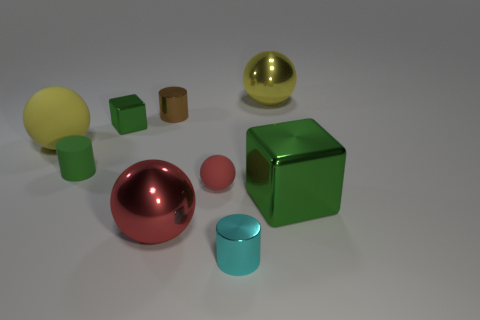The rubber thing that is the same color as the big metal cube is what size?
Ensure brevity in your answer.  Small. What number of other things are the same size as the brown cylinder?
Offer a terse response. 4. There is a green block that is behind the small green rubber cylinder; what is its material?
Your answer should be very brief. Metal. Do the yellow metal object and the cyan thing have the same shape?
Make the answer very short. No. How many other things are the same shape as the large green thing?
Your answer should be very brief. 1. What is the color of the metallic sphere that is to the right of the red shiny sphere?
Your response must be concise. Yellow. Is the red matte ball the same size as the brown object?
Provide a short and direct response. Yes. What material is the green cube that is left of the metal block that is right of the small ball?
Your answer should be very brief. Metal. How many matte cylinders have the same color as the big metal block?
Keep it short and to the point. 1. Are there any other things that are the same material as the small ball?
Offer a very short reply. Yes. 